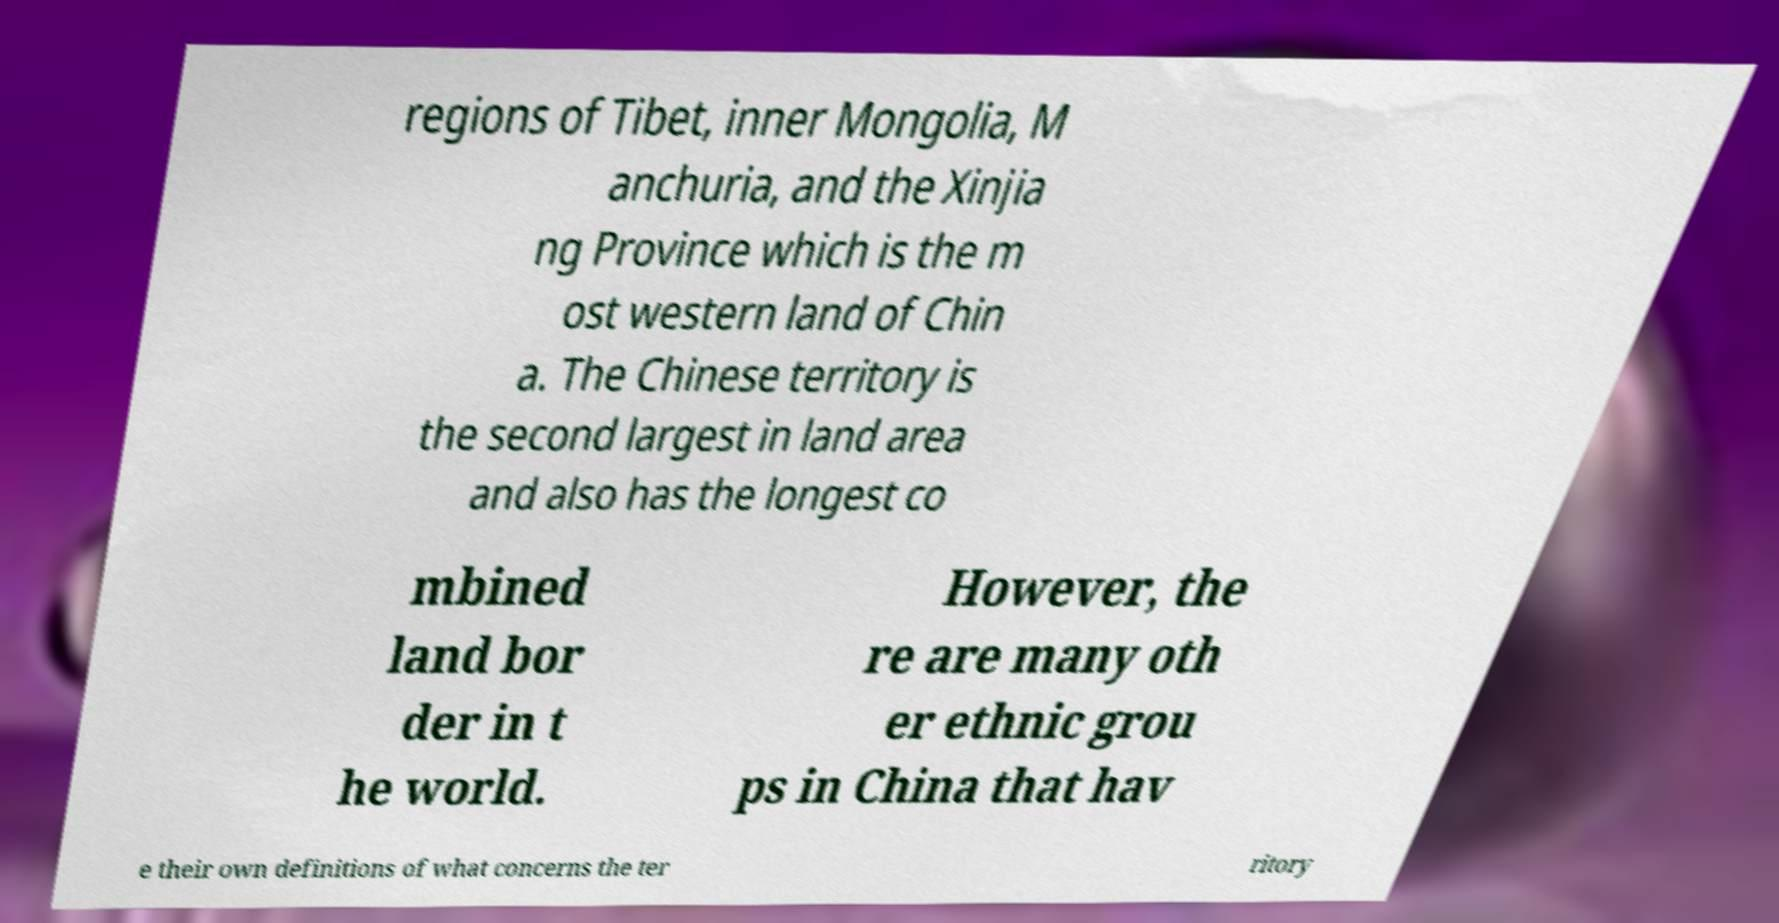I need the written content from this picture converted into text. Can you do that? regions of Tibet, inner Mongolia, M anchuria, and the Xinjia ng Province which is the m ost western land of Chin a. The Chinese territory is the second largest in land area and also has the longest co mbined land bor der in t he world. However, the re are many oth er ethnic grou ps in China that hav e their own definitions of what concerns the ter ritory 